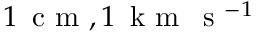Convert formula to latex. <formula><loc_0><loc_0><loc_500><loc_500>1 \, c m , 1 \, k m \, s ^ { - 1 }</formula> 